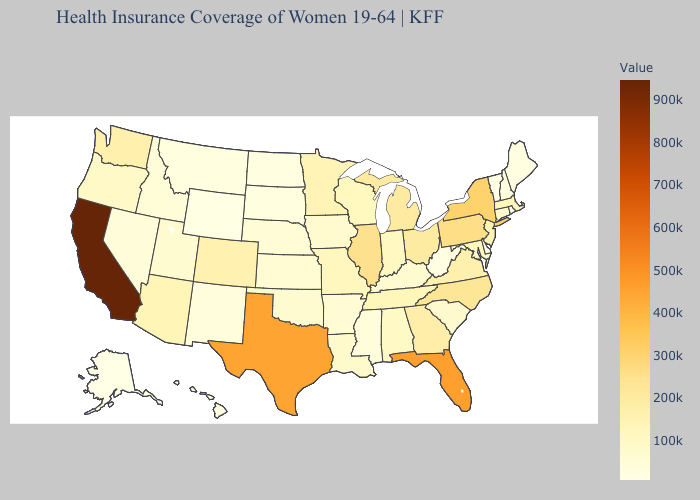Does Illinois have the highest value in the USA?
Keep it brief. No. Does California have the highest value in the West?
Answer briefly. Yes. Among the states that border Arkansas , which have the highest value?
Give a very brief answer. Texas. Which states hav the highest value in the MidWest?
Quick response, please. Illinois. Does Minnesota have a higher value than West Virginia?
Concise answer only. Yes. Which states have the lowest value in the USA?
Be succinct. Alaska. Among the states that border Pennsylvania , does New York have the highest value?
Short answer required. Yes. 